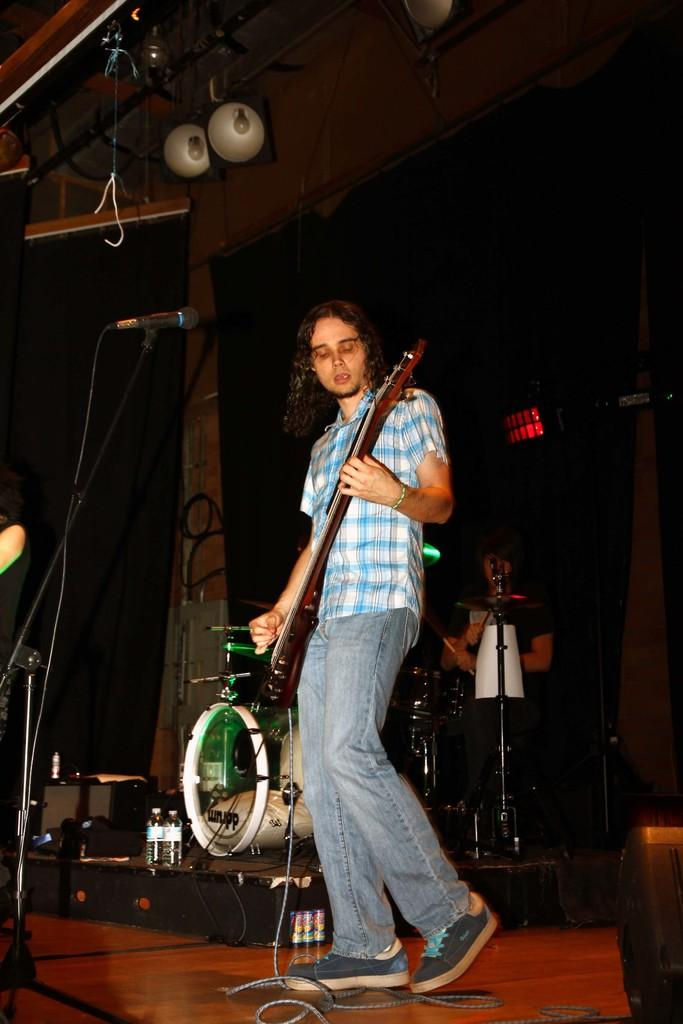What is the person in the image doing? The person is standing in front of a mic and holding a guitar. What instrument can be seen in the background of the image? There is a drum set in the background of the image. What is the person holding in their hands? The person is holding a guitar. What type of feast is being prepared in the image? There is no feast being prepared in the image; it features a person with a guitar and a drum set in the background. How many brothers are visible in the image? There are no brothers present in the image. 